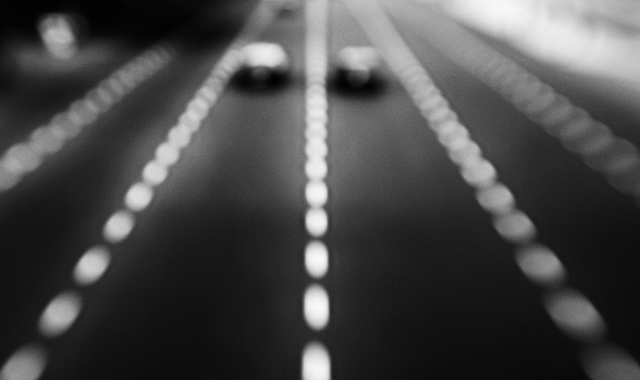Could this photo be effectively used in advertising or as art? What message might it convey? Indeed, the abstract and dynamic nature of this photo means it might be well-suited to contexts such as advertising for high-speed services or products like sports cars or fast internet. As an artistic piece, it speaks to themes of transience, the rush of modern life, or the beauty found in fleeting moments. It could prompt viewers to consider their own experiences of time and motion. 